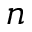<formula> <loc_0><loc_0><loc_500><loc_500>n</formula> 